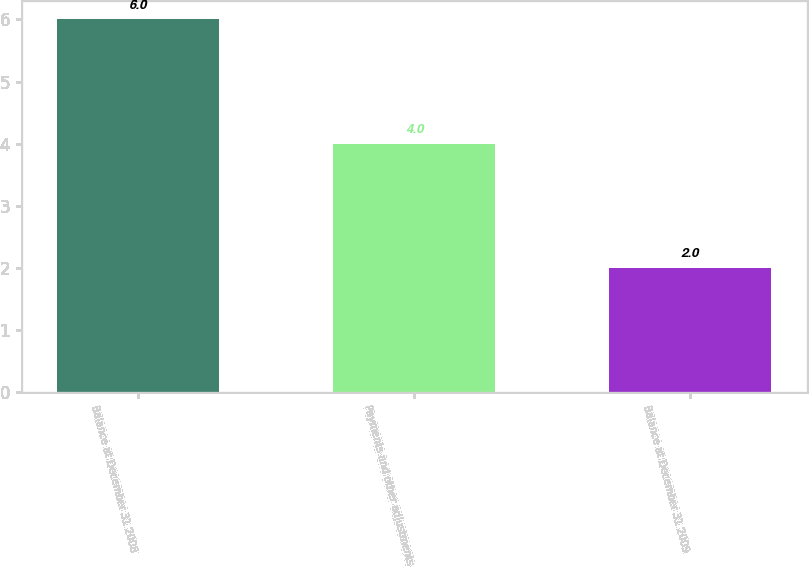<chart> <loc_0><loc_0><loc_500><loc_500><bar_chart><fcel>Balance at December 31 2008<fcel>Payments and other adjustments<fcel>Balance at December 31 2009<nl><fcel>6<fcel>4<fcel>2<nl></chart> 